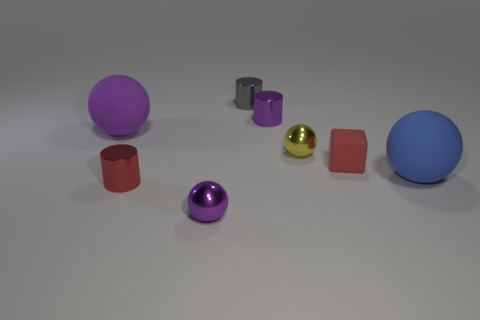Is the number of purple metal cylinders that are behind the small gray shiny cylinder the same as the number of gray shiny things?
Ensure brevity in your answer.  No. What color is the large thing that is on the right side of the big purple rubber thing?
Your response must be concise. Blue. How many other objects are the same color as the block?
Make the answer very short. 1. Are there any other things that are the same size as the gray cylinder?
Give a very brief answer. Yes. Does the cylinder that is in front of the rubber block have the same size as the tiny red matte object?
Your response must be concise. Yes. There is a small red thing to the right of the small gray thing; what is it made of?
Your answer should be compact. Rubber. Is there any other thing that is the same shape as the gray object?
Give a very brief answer. Yes. What number of shiny things are small yellow things or large blue cubes?
Keep it short and to the point. 1. Is the number of rubber objects behind the large blue matte sphere less than the number of small red rubber objects?
Offer a very short reply. No. There is a rubber object that is on the left side of the tiny shiny ball that is to the right of the gray metallic object that is left of the red rubber object; what shape is it?
Make the answer very short. Sphere. 